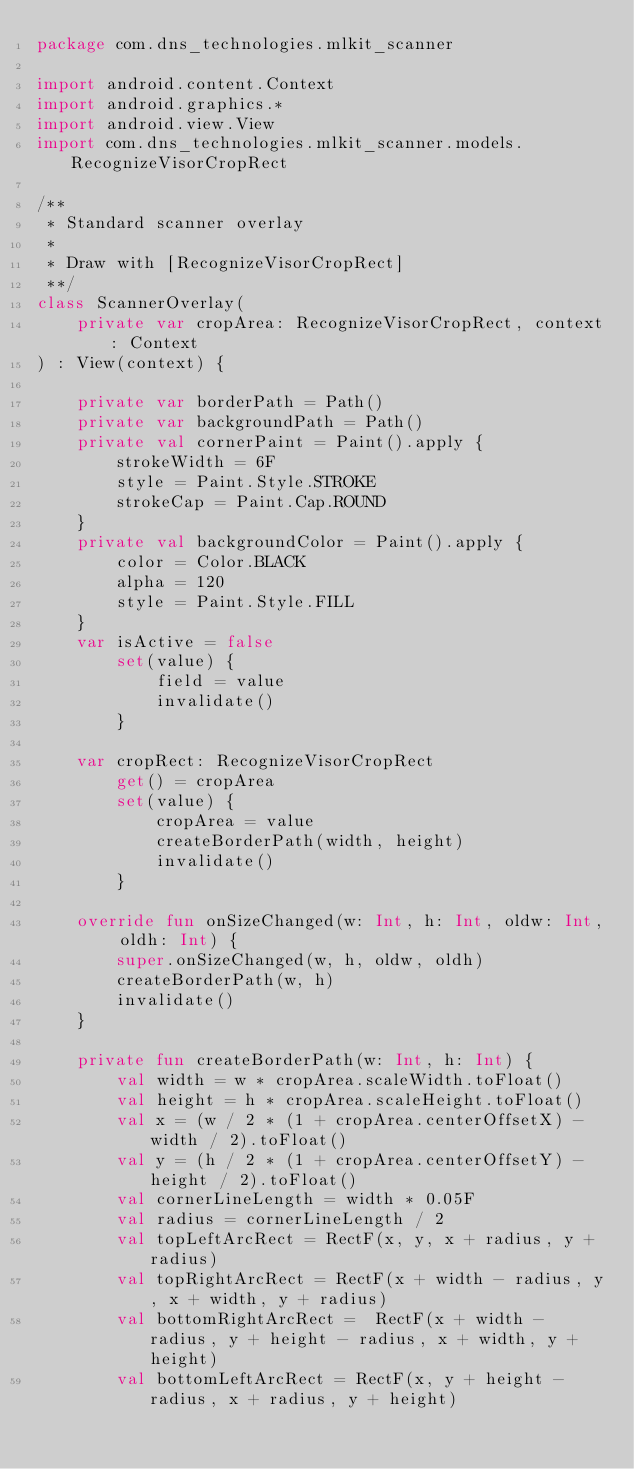<code> <loc_0><loc_0><loc_500><loc_500><_Kotlin_>package com.dns_technologies.mlkit_scanner

import android.content.Context
import android.graphics.*
import android.view.View
import com.dns_technologies.mlkit_scanner.models.RecognizeVisorCropRect

/**
 * Standard scanner overlay
 *
 * Draw with [RecognizeVisorCropRect]
 **/
class ScannerOverlay(
    private var cropArea: RecognizeVisorCropRect, context: Context
) : View(context) {

    private var borderPath = Path()
    private var backgroundPath = Path()
    private val cornerPaint = Paint().apply {
        strokeWidth = 6F
        style = Paint.Style.STROKE
        strokeCap = Paint.Cap.ROUND
    }
    private val backgroundColor = Paint().apply {
        color = Color.BLACK
        alpha = 120
        style = Paint.Style.FILL
    }
    var isActive = false
        set(value) {
            field = value
            invalidate()
        }

    var cropRect: RecognizeVisorCropRect
        get() = cropArea
        set(value) {
            cropArea = value
            createBorderPath(width, height)
            invalidate()
        }

    override fun onSizeChanged(w: Int, h: Int, oldw: Int, oldh: Int) {
        super.onSizeChanged(w, h, oldw, oldh)
        createBorderPath(w, h)
        invalidate()
    }

    private fun createBorderPath(w: Int, h: Int) {
        val width = w * cropArea.scaleWidth.toFloat()
        val height = h * cropArea.scaleHeight.toFloat()
        val x = (w / 2 * (1 + cropArea.centerOffsetX) - width / 2).toFloat()
        val y = (h / 2 * (1 + cropArea.centerOffsetY) - height / 2).toFloat()
        val cornerLineLength = width * 0.05F
        val radius = cornerLineLength / 2
        val topLeftArcRect = RectF(x, y, x + radius, y + radius)
        val topRightArcRect = RectF(x + width - radius, y, x + width, y + radius)
        val bottomRightArcRect =  RectF(x + width - radius, y + height - radius, x + width, y + height)
        val bottomLeftArcRect = RectF(x, y + height - radius, x + radius, y + height)</code> 